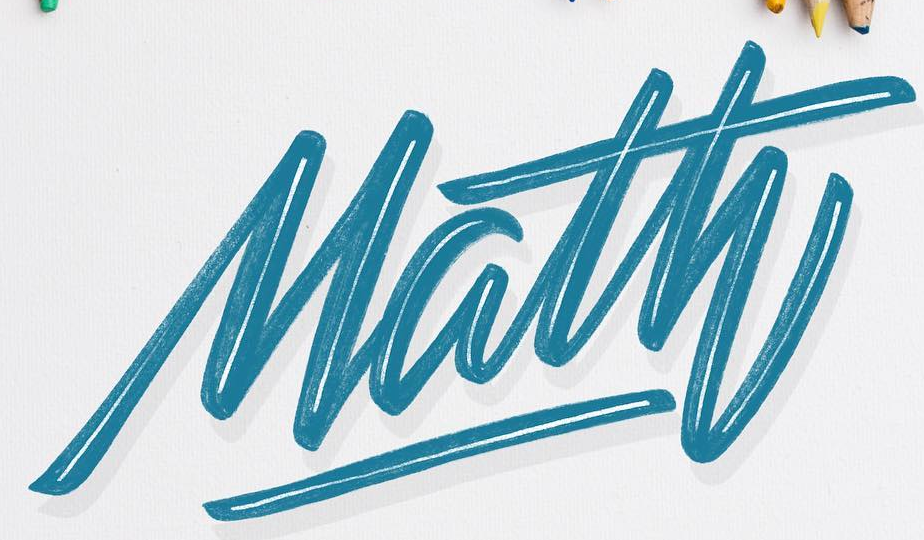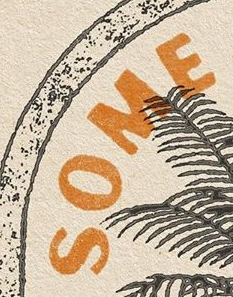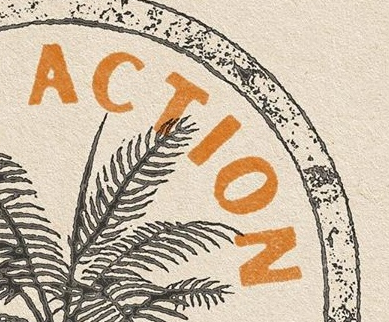What words are shown in these images in order, separated by a semicolon? Math; SOME; ACTION 